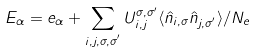Convert formula to latex. <formula><loc_0><loc_0><loc_500><loc_500>E _ { \alpha } = e _ { \alpha } + \sum _ { i , j , \sigma , \sigma ^ { ^ { \prime } } } U _ { i , j } ^ { \sigma , \sigma ^ { \prime } } \langle \hat { n } _ { i , \sigma } \hat { n } _ { j , \sigma ^ { ^ { \prime } } } \rangle / N _ { e }</formula> 